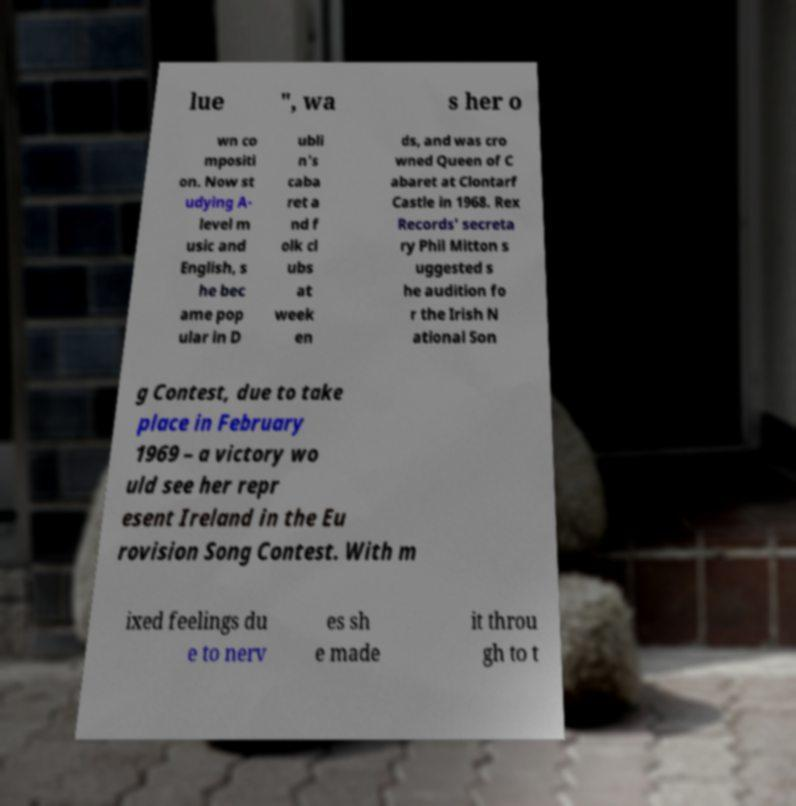Can you read and provide the text displayed in the image?This photo seems to have some interesting text. Can you extract and type it out for me? lue ", wa s her o wn co mpositi on. Now st udying A- level m usic and English, s he bec ame pop ular in D ubli n's caba ret a nd f olk cl ubs at week en ds, and was cro wned Queen of C abaret at Clontarf Castle in 1968. Rex Records' secreta ry Phil Mitton s uggested s he audition fo r the Irish N ational Son g Contest, due to take place in February 1969 – a victory wo uld see her repr esent Ireland in the Eu rovision Song Contest. With m ixed feelings du e to nerv es sh e made it throu gh to t 